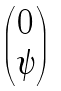Convert formula to latex. <formula><loc_0><loc_0><loc_500><loc_500>\begin{pmatrix} 0 \\ \psi \end{pmatrix}</formula> 